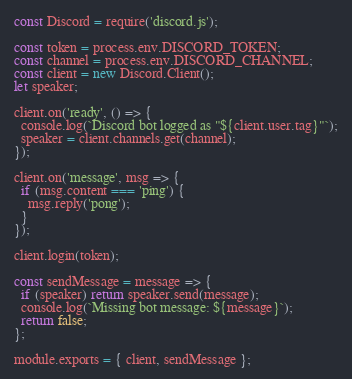Convert code to text. <code><loc_0><loc_0><loc_500><loc_500><_JavaScript_>const Discord = require('discord.js');

const token = process.env.DISCORD_TOKEN;
const channel = process.env.DISCORD_CHANNEL;
const client = new Discord.Client();
let speaker;

client.on('ready', () => {
  console.log(`Discord bot logged as "${client.user.tag}"`);
  speaker = client.channels.get(channel);
});

client.on('message', msg => {
  if (msg.content === 'ping') {
    msg.reply('pong');
  }
});

client.login(token);

const sendMessage = message => {
  if (speaker) return speaker.send(message);
  console.log(`Missing bot message: ${message}`);
  return false;
};

module.exports = { client, sendMessage };
</code> 